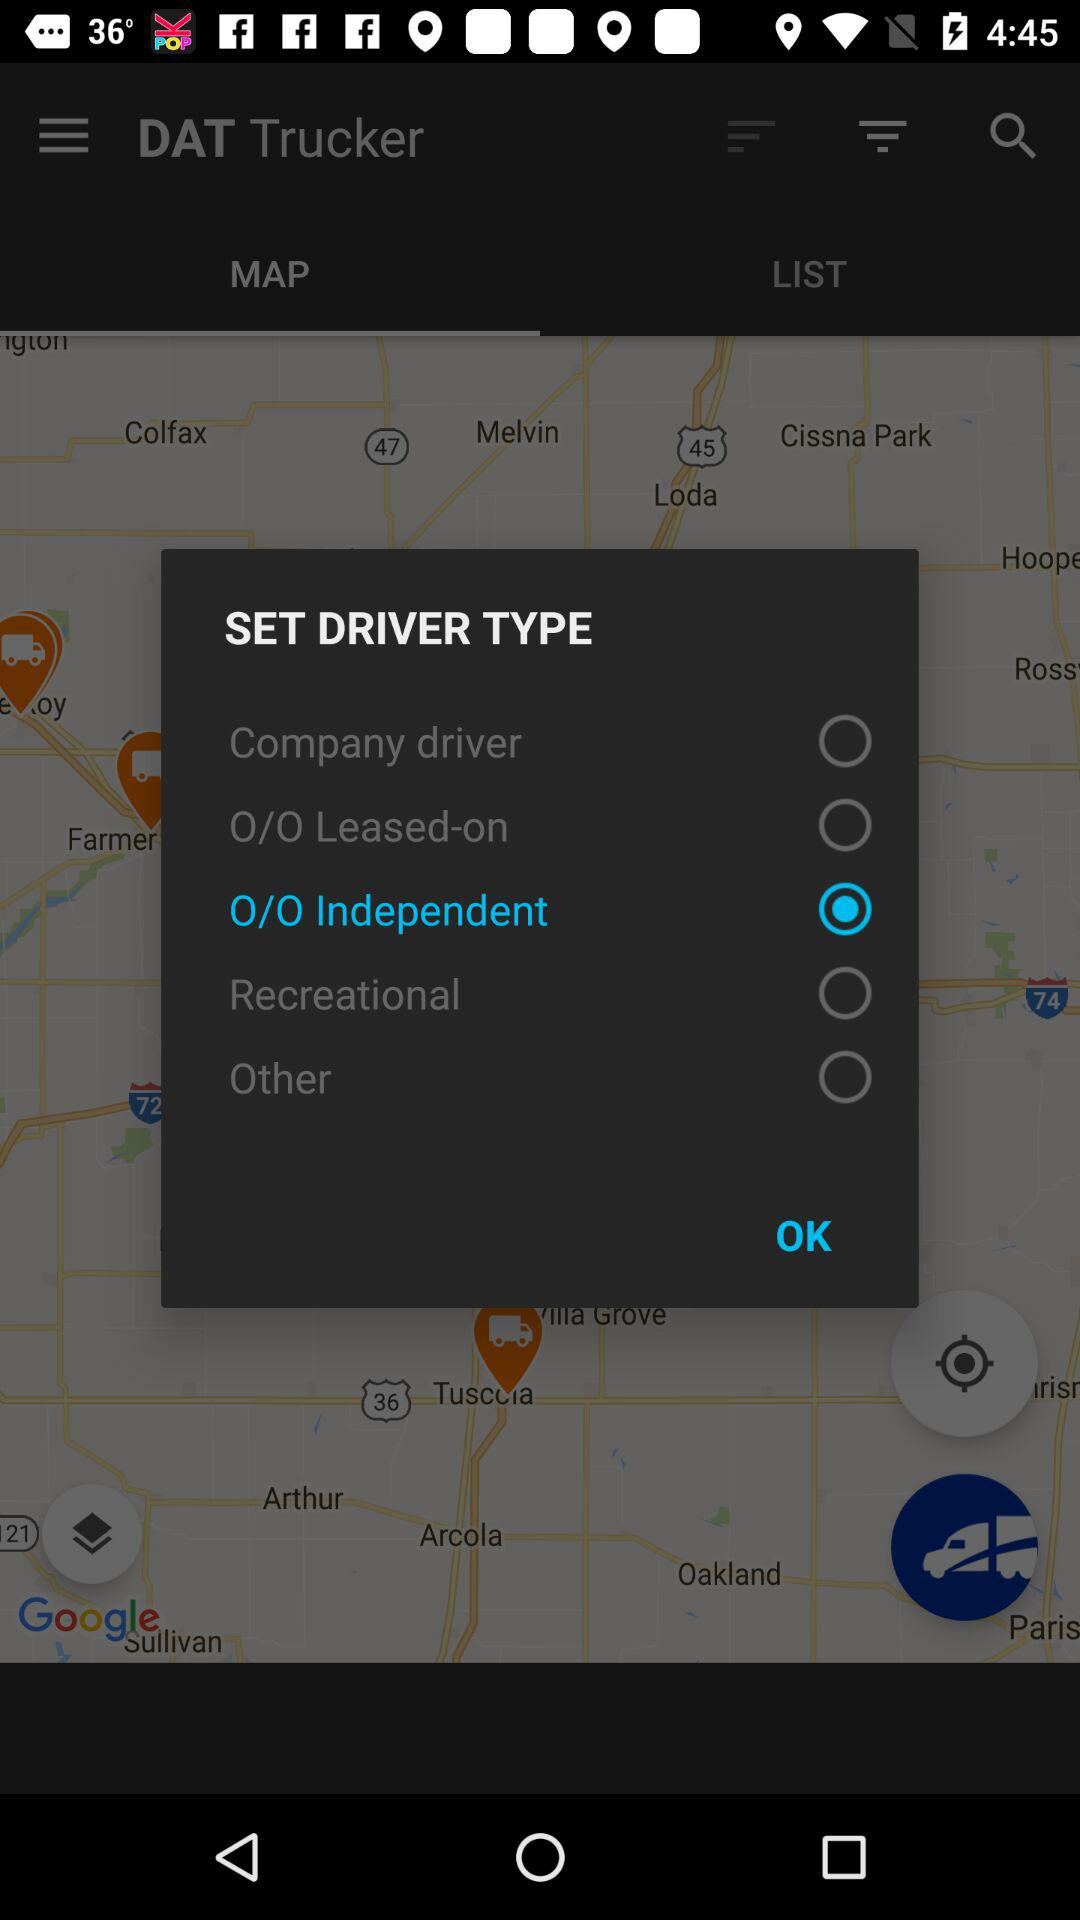How many options are available for driver type?
Answer the question using a single word or phrase. 5 